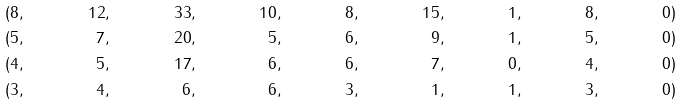Convert formula to latex. <formula><loc_0><loc_0><loc_500><loc_500>& & ( 8 & , & 1 2 & , & 3 3 & , & 1 0 & , & 8 & , & 1 5 & , & 1 & , & 8 & , & 0 & ) & & & & \\ & & ( 5 & , & 7 & , & 2 0 & , & 5 & , & 6 & , & 9 & , & 1 & , & 5 & , & 0 & ) & & & & \\ & & ( 4 & , & 5 & , & 1 7 & , & 6 & , & 6 & , & 7 & , & 0 & , & 4 & , & 0 & ) & & & & \\ & & ( 3 & , & 4 & , & 6 & , & 6 & , & 3 & , & 1 & , & 1 & , & 3 & , & 0 & ) & & & &</formula> 